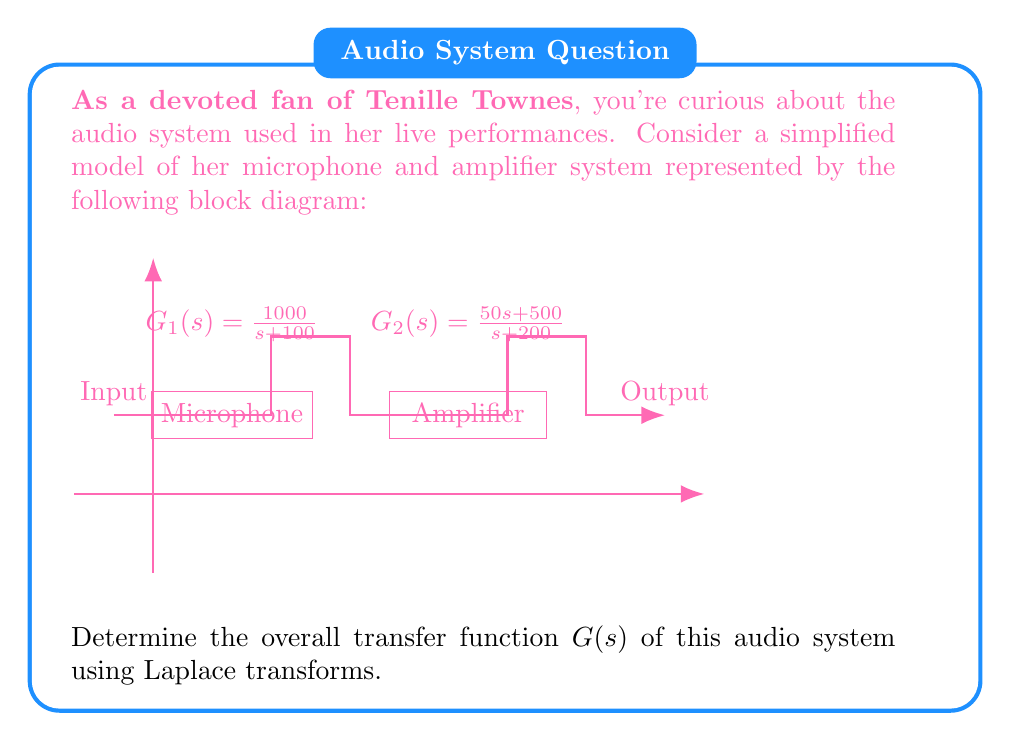Help me with this question. Let's approach this step-by-step:

1) The system consists of two components in series: the microphone ($G_1(s)$) and the amplifier ($G_2(s)$).

2) For systems in series, we multiply their individual transfer functions to get the overall transfer function. So:

   $$G(s) = G_1(s) \cdot G_2(s)$$

3) Let's substitute the given transfer functions:

   $$G(s) = \frac{1000}{s+100} \cdot \frac{50s+500}{s+200}$$

4) Multiply the numerators and denominators:

   $$G(s) = \frac{1000(50s+500)}{(s+100)(s+200)}$$

5) Simplify the numerator:

   $$G(s) = \frac{50000s+500000}{(s+100)(s+200)}$$

6) Expand the denominator:

   $$G(s) = \frac{50000s+500000}{s^2+300s+20000}$$

This is the overall transfer function of the audio system.
Answer: $$G(s) = \frac{50000s+500000}{s^2+300s+20000}$$ 